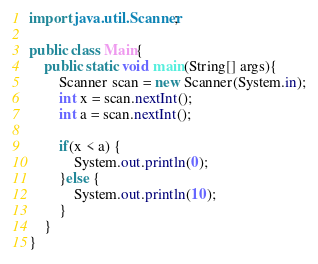Convert code to text. <code><loc_0><loc_0><loc_500><loc_500><_Java_>import java.util.Scanner;

public class Main{
	public static void main(String[] args){
		Scanner scan = new Scanner(System.in);
		int x = scan.nextInt();
		int a = scan.nextInt();

		if(x < a) {
			System.out.println(0);
		}else {
			System.out.println(10);
		}
	}
}
</code> 